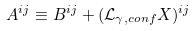<formula> <loc_0><loc_0><loc_500><loc_500>A ^ { i j } \equiv B ^ { i j } + ( \mathcal { L } _ { \gamma , c o n f } X ) ^ { i j }</formula> 